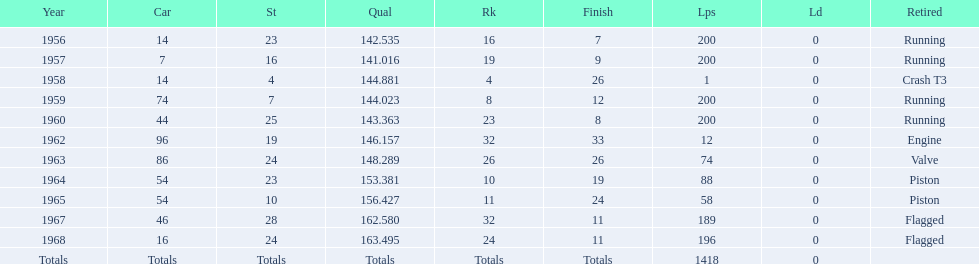What was the last year that it finished the race? 1968. 